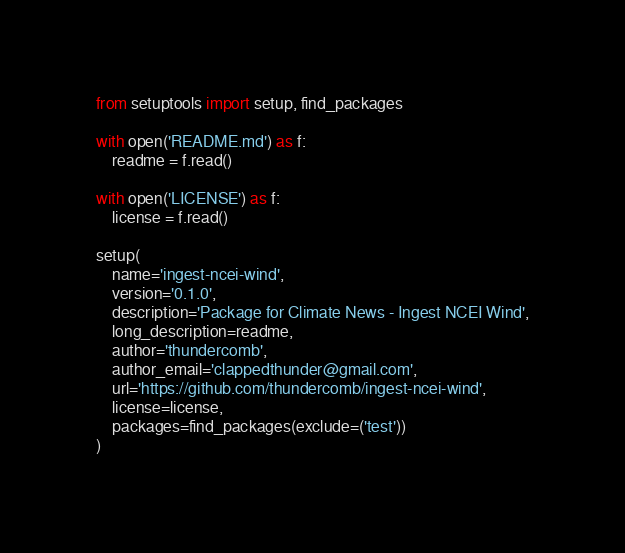<code> <loc_0><loc_0><loc_500><loc_500><_Python_>from setuptools import setup, find_packages

with open('README.md') as f:
    readme = f.read()

with open('LICENSE') as f:
    license = f.read()

setup(
    name='ingest-ncei-wind',
    version='0.1.0',
    description='Package for Climate News - Ingest NCEI Wind',
    long_description=readme,
    author='thundercomb',
    author_email='clappedthunder@gmail.com',
    url='https://github.com/thundercomb/ingest-ncei-wind',
    license=license,
    packages=find_packages(exclude=('test'))
)
</code> 